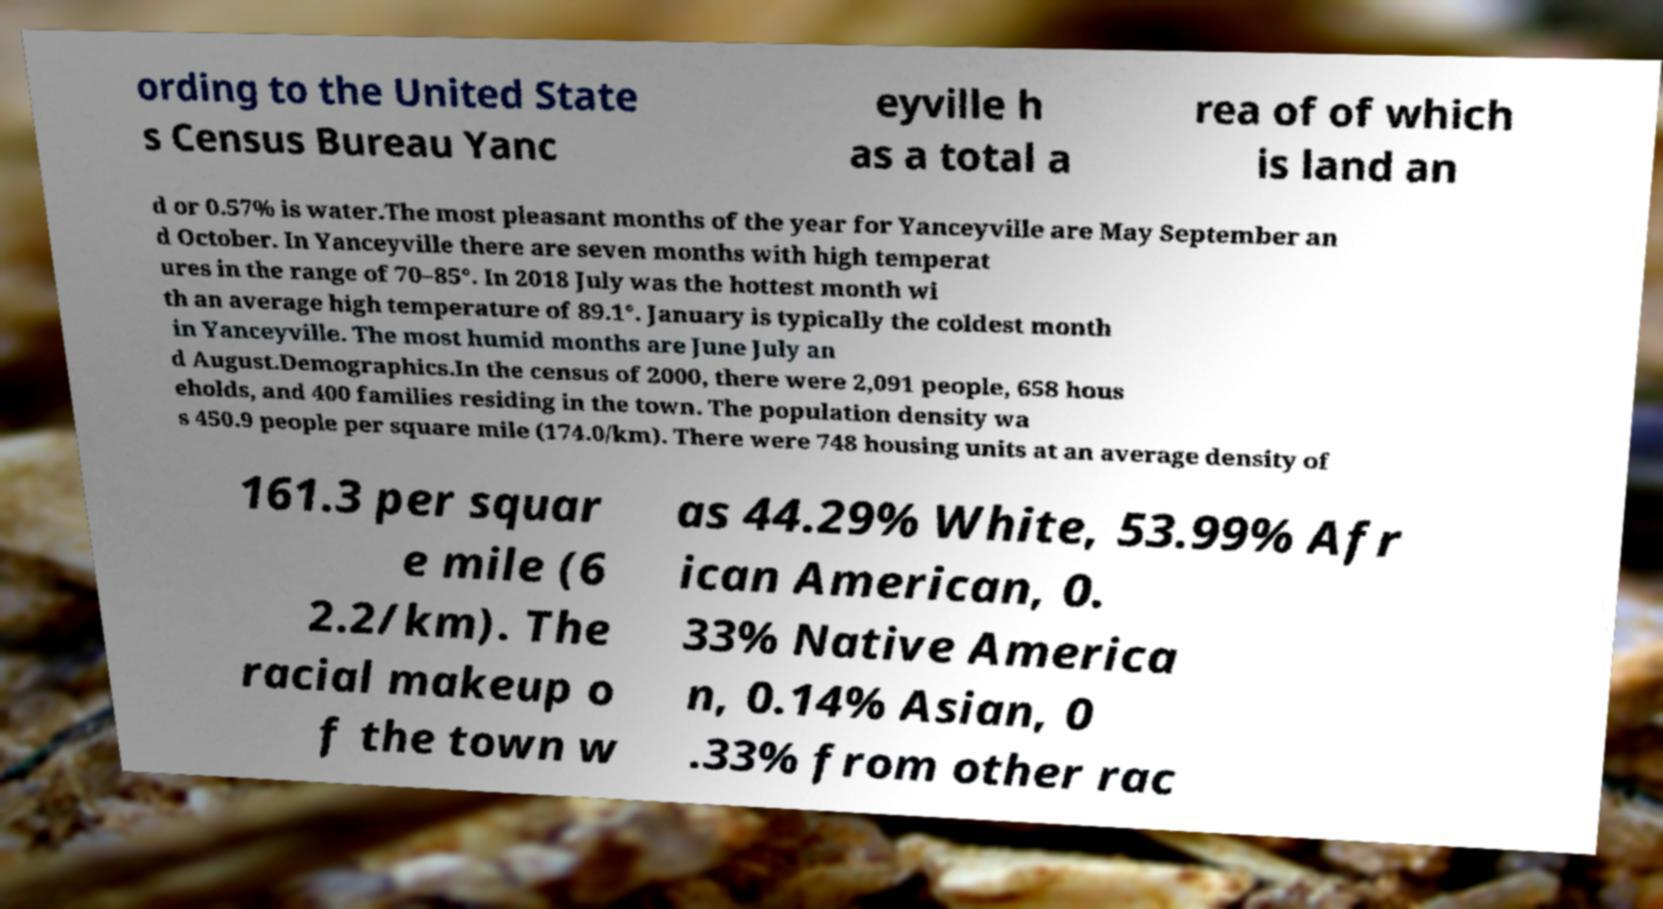I need the written content from this picture converted into text. Can you do that? ording to the United State s Census Bureau Yanc eyville h as a total a rea of of which is land an d or 0.57% is water.The most pleasant months of the year for Yanceyville are May September an d October. In Yanceyville there are seven months with high temperat ures in the range of 70–85°. In 2018 July was the hottest month wi th an average high temperature of 89.1°. January is typically the coldest month in Yanceyville. The most humid months are June July an d August.Demographics.In the census of 2000, there were 2,091 people, 658 hous eholds, and 400 families residing in the town. The population density wa s 450.9 people per square mile (174.0/km). There were 748 housing units at an average density of 161.3 per squar e mile (6 2.2/km). The racial makeup o f the town w as 44.29% White, 53.99% Afr ican American, 0. 33% Native America n, 0.14% Asian, 0 .33% from other rac 